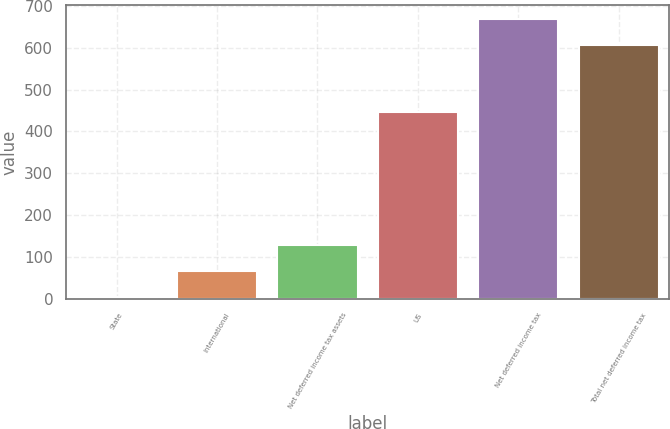Convert chart. <chart><loc_0><loc_0><loc_500><loc_500><bar_chart><fcel>State<fcel>International<fcel>Net deferred income tax assets<fcel>US<fcel>Net deferred income tax<fcel>Total net deferred income tax<nl><fcel>3.9<fcel>66.16<fcel>128.42<fcel>446.2<fcel>667.96<fcel>605.7<nl></chart> 